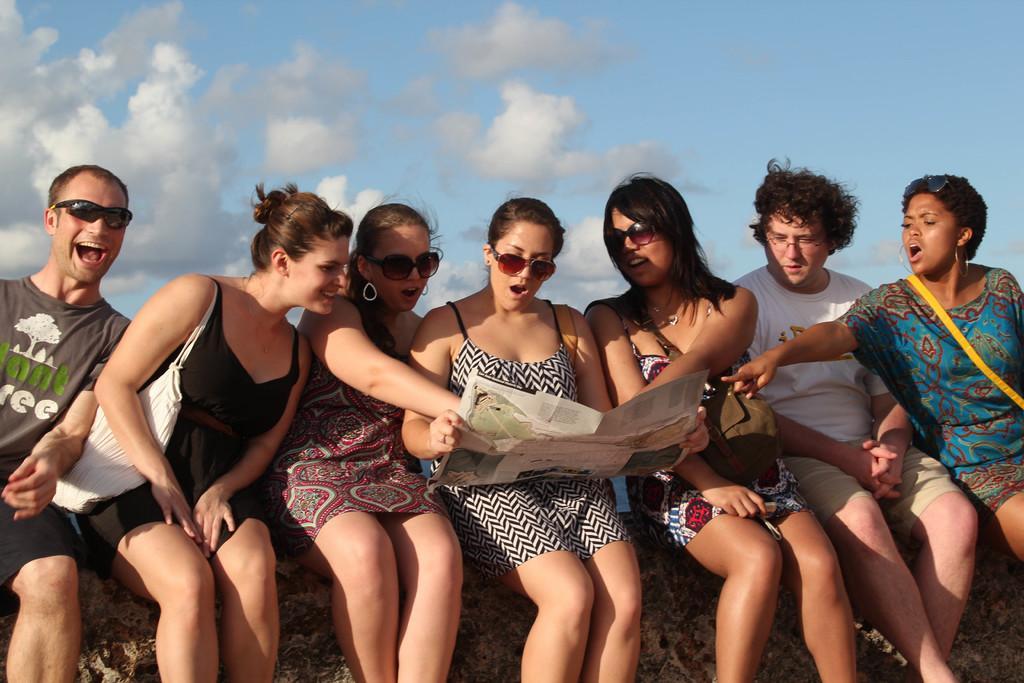Can you describe this image briefly? In this image I see 5 women and 2 men who are sitting and I see that this woman is holding the paper and I see that these both of them are smiling. In the background I see the sky which is of blue and white in color and I see that it is a bit cloudy. 